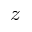<formula> <loc_0><loc_0><loc_500><loc_500>z</formula> 